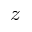<formula> <loc_0><loc_0><loc_500><loc_500>z</formula> 